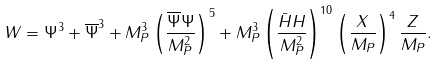Convert formula to latex. <formula><loc_0><loc_0><loc_500><loc_500>W = \Psi ^ { 3 } + \overline { \Psi } ^ { 3 } + M _ { P } ^ { 3 } \left ( \frac { \overline { \Psi } \Psi } { M _ { P } ^ { 2 } } \right ) ^ { 5 } + M _ { P } ^ { 3 } \left ( \frac { \bar { H } H } { M _ { P } ^ { 2 } } \right ) ^ { 1 0 } \left ( \frac { X } { M _ { P } } \right ) ^ { 4 } \frac { Z } { M _ { P } } .</formula> 